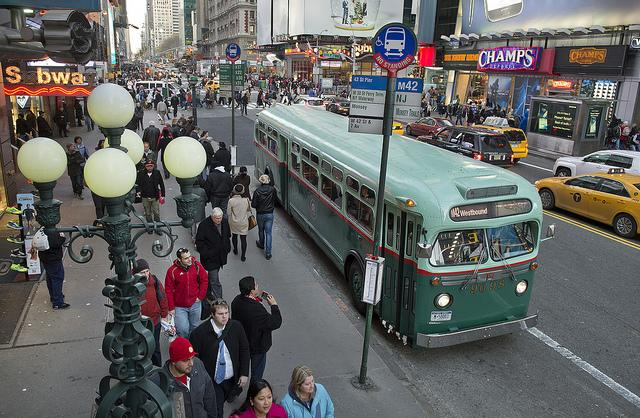Why are only the letters SBwa visible on that sign?

Choices:
A) broken bulbs
B) correct name
C) spray paint
D) fallen letters broken bulbs 